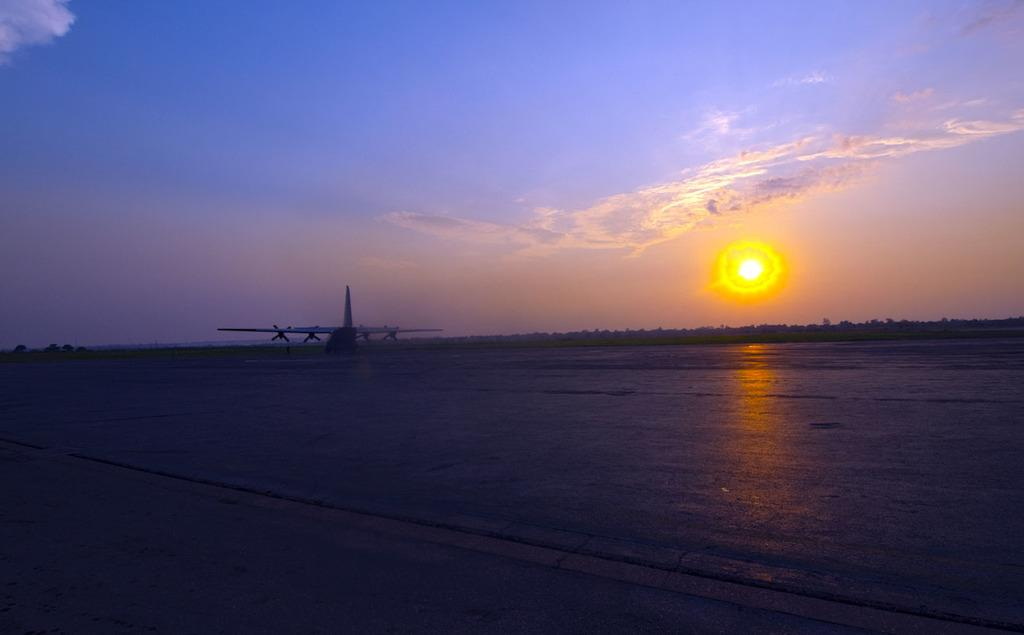What is the main subject of the image? The main subject of the image is an aeroplane. What is located at the bottom of the image? There is a runway at the bottom of the image. What can be seen in the background of the image? The sun and the sky are visible in the background of the image. What type of clover is growing on the runway in the image? There is no clover present in the image, and the runway is not a place where plants typically grow. 